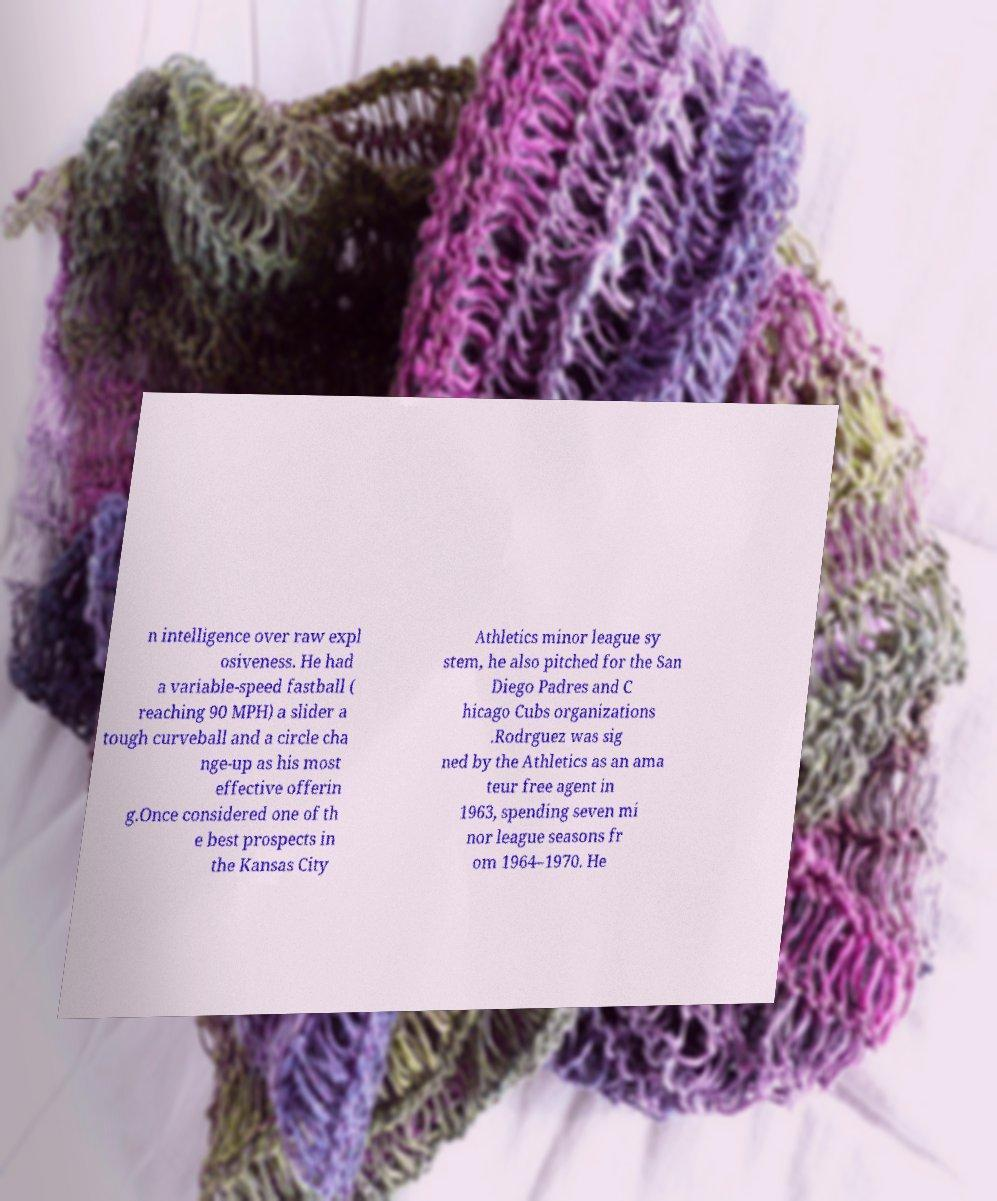Can you read and provide the text displayed in the image?This photo seems to have some interesting text. Can you extract and type it out for me? n intelligence over raw expl osiveness. He had a variable-speed fastball ( reaching 90 MPH) a slider a tough curveball and a circle cha nge-up as his most effective offerin g.Once considered one of th e best prospects in the Kansas City Athletics minor league sy stem, he also pitched for the San Diego Padres and C hicago Cubs organizations .Rodrguez was sig ned by the Athletics as an ama teur free agent in 1963, spending seven mi nor league seasons fr om 1964–1970. He 